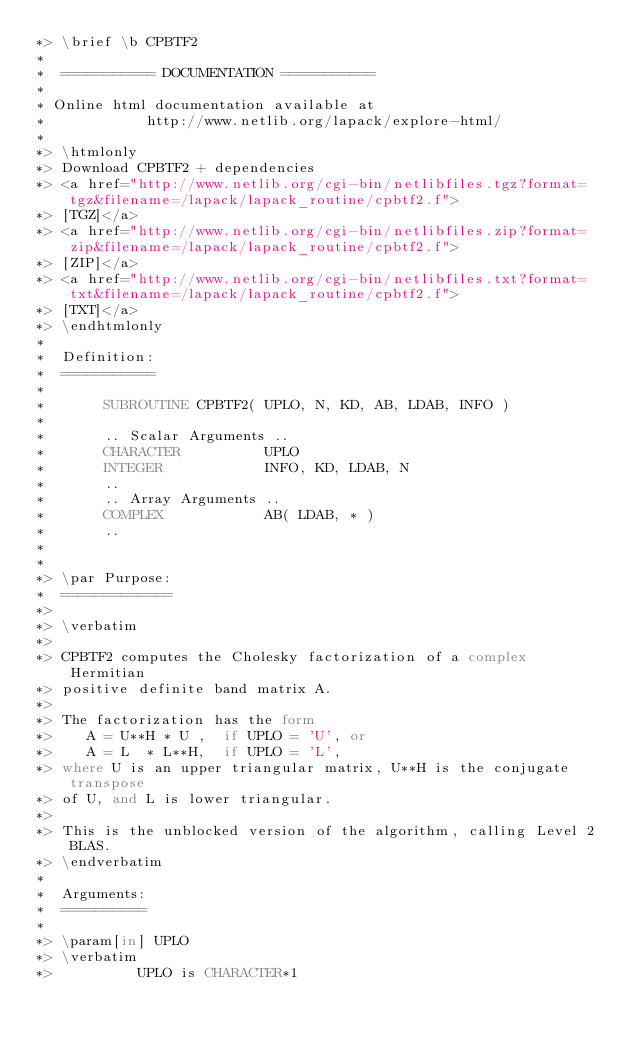<code> <loc_0><loc_0><loc_500><loc_500><_FORTRAN_>*> \brief \b CPBTF2
*
*  =========== DOCUMENTATION ===========
*
* Online html documentation available at 
*            http://www.netlib.org/lapack/explore-html/ 
*
*> \htmlonly
*> Download CPBTF2 + dependencies 
*> <a href="http://www.netlib.org/cgi-bin/netlibfiles.tgz?format=tgz&filename=/lapack/lapack_routine/cpbtf2.f"> 
*> [TGZ]</a> 
*> <a href="http://www.netlib.org/cgi-bin/netlibfiles.zip?format=zip&filename=/lapack/lapack_routine/cpbtf2.f"> 
*> [ZIP]</a> 
*> <a href="http://www.netlib.org/cgi-bin/netlibfiles.txt?format=txt&filename=/lapack/lapack_routine/cpbtf2.f"> 
*> [TXT]</a>
*> \endhtmlonly 
*
*  Definition:
*  ===========
*
*       SUBROUTINE CPBTF2( UPLO, N, KD, AB, LDAB, INFO )
* 
*       .. Scalar Arguments ..
*       CHARACTER          UPLO
*       INTEGER            INFO, KD, LDAB, N
*       ..
*       .. Array Arguments ..
*       COMPLEX            AB( LDAB, * )
*       ..
*  
*
*> \par Purpose:
*  =============
*>
*> \verbatim
*>
*> CPBTF2 computes the Cholesky factorization of a complex Hermitian
*> positive definite band matrix A.
*>
*> The factorization has the form
*>    A = U**H * U ,  if UPLO = 'U', or
*>    A = L  * L**H,  if UPLO = 'L',
*> where U is an upper triangular matrix, U**H is the conjugate transpose
*> of U, and L is lower triangular.
*>
*> This is the unblocked version of the algorithm, calling Level 2 BLAS.
*> \endverbatim
*
*  Arguments:
*  ==========
*
*> \param[in] UPLO
*> \verbatim
*>          UPLO is CHARACTER*1</code> 